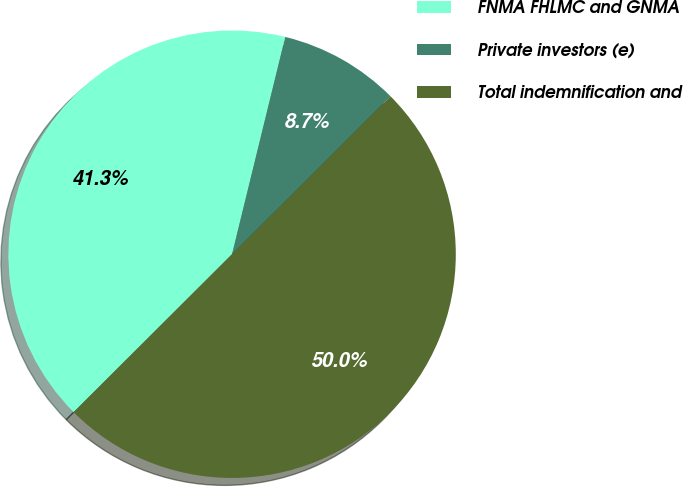<chart> <loc_0><loc_0><loc_500><loc_500><pie_chart><fcel>FNMA FHLMC and GNMA<fcel>Private investors (e)<fcel>Total indemnification and<nl><fcel>41.3%<fcel>8.7%<fcel>50.0%<nl></chart> 